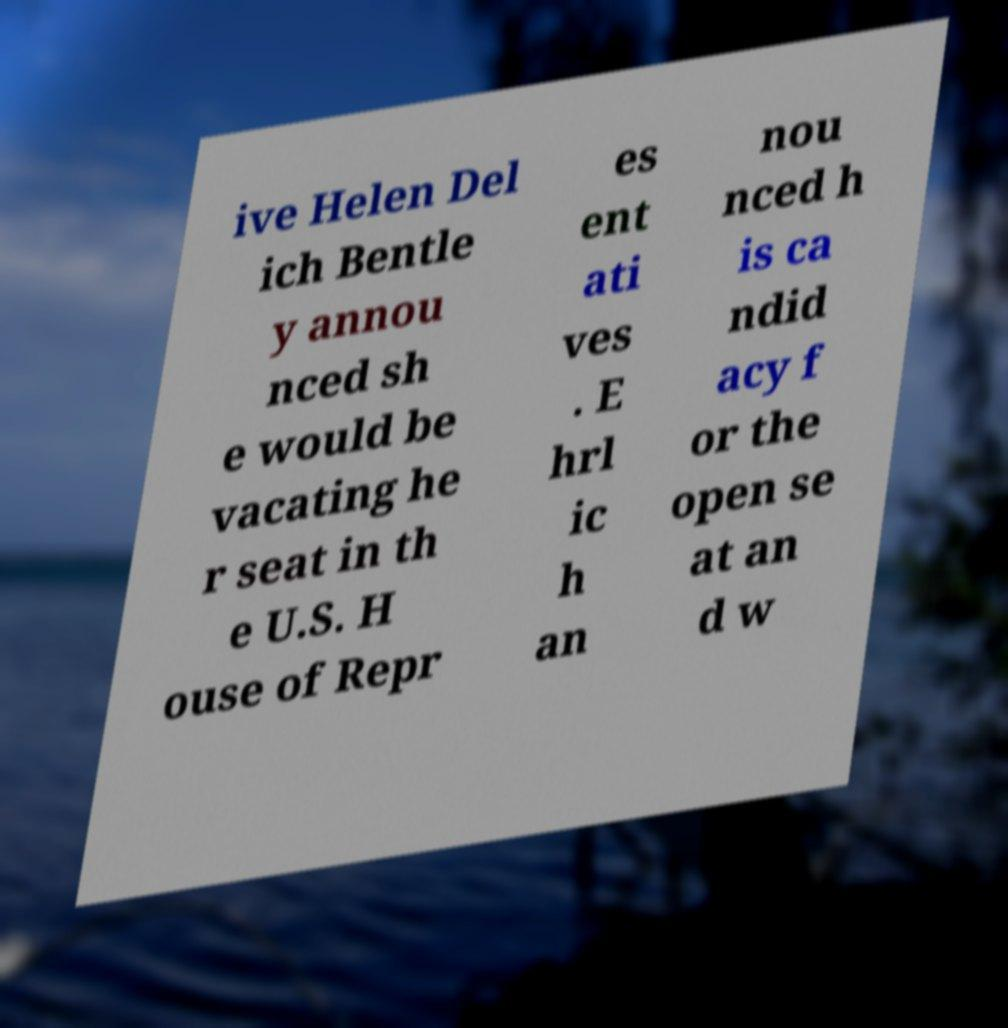Could you assist in decoding the text presented in this image and type it out clearly? ive Helen Del ich Bentle y annou nced sh e would be vacating he r seat in th e U.S. H ouse of Repr es ent ati ves . E hrl ic h an nou nced h is ca ndid acy f or the open se at an d w 